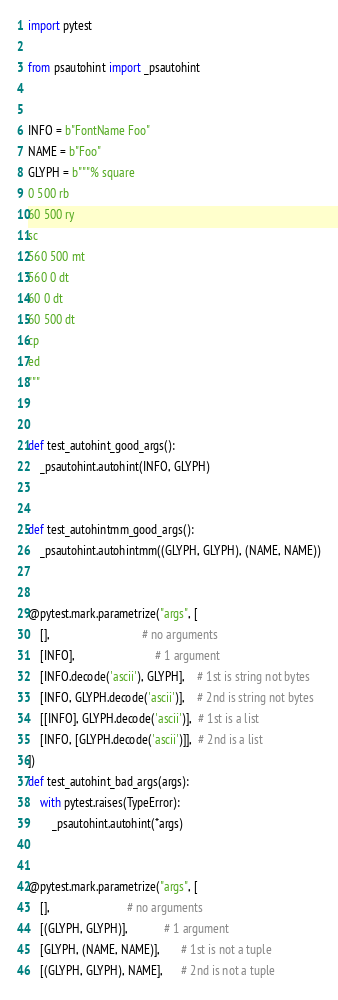<code> <loc_0><loc_0><loc_500><loc_500><_Python_>import pytest

from psautohint import _psautohint


INFO = b"FontName Foo"
NAME = b"Foo"
GLYPH = b"""% square
0 500 rb
60 500 ry
sc
560 500 mt
560 0 dt
60 0 dt
60 500 dt
cp
ed
"""


def test_autohint_good_args():
    _psautohint.autohint(INFO, GLYPH)


def test_autohintmm_good_args():
    _psautohint.autohintmm((GLYPH, GLYPH), (NAME, NAME))


@pytest.mark.parametrize("args", [
    [],                               # no arguments
    [INFO],                           # 1 argument
    [INFO.decode('ascii'), GLYPH],    # 1st is string not bytes
    [INFO, GLYPH.decode('ascii')],    # 2nd is string not bytes
    [[INFO], GLYPH.decode('ascii')],  # 1st is a list
    [INFO, [GLYPH.decode('ascii')]],  # 2nd is a list
])
def test_autohint_bad_args(args):
    with pytest.raises(TypeError):
        _psautohint.autohint(*args)


@pytest.mark.parametrize("args", [
    [],                          # no arguments
    [(GLYPH, GLYPH)],            # 1 argument
    [GLYPH, (NAME, NAME)],       # 1st is not a tuple
    [(GLYPH, GLYPH), NAME],      # 2nd is not a tuple</code> 